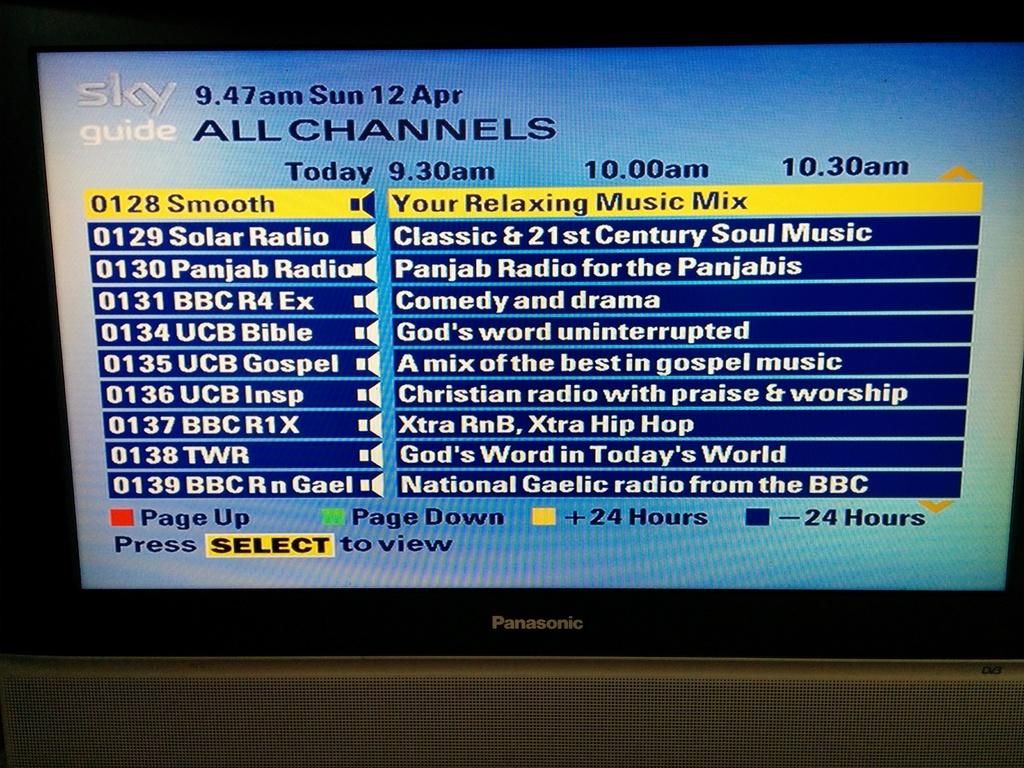What is the time shown?
Your answer should be compact. 9:47 am. What time is displayed?
Provide a short and direct response. 9:47. 